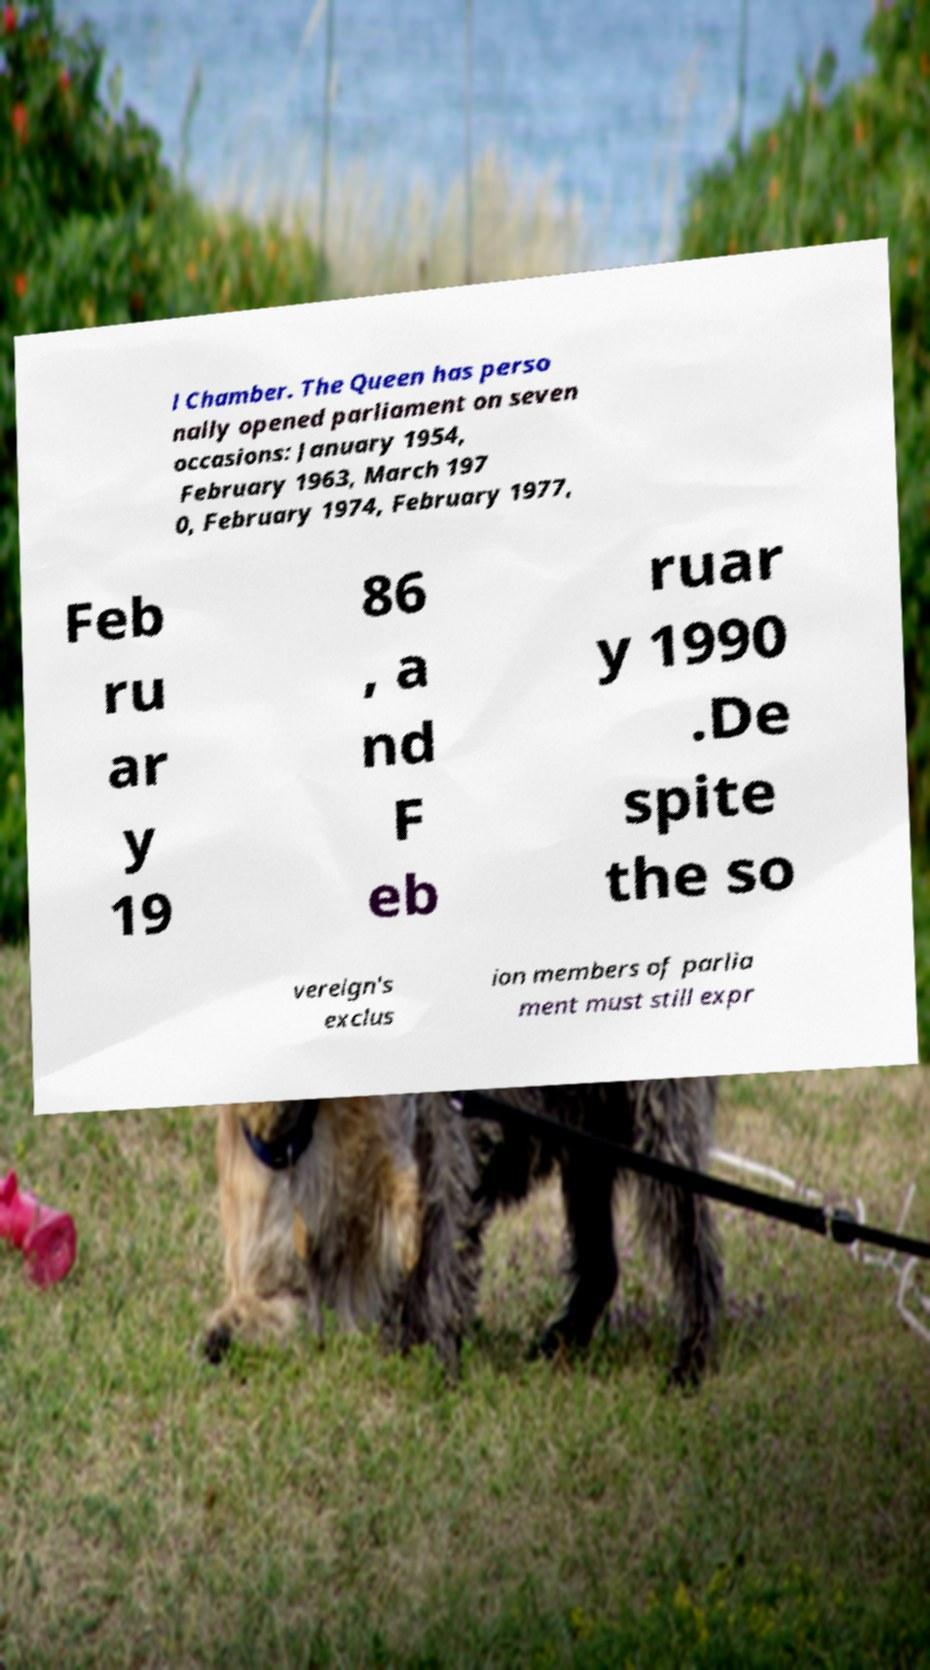For documentation purposes, I need the text within this image transcribed. Could you provide that? l Chamber. The Queen has perso nally opened parliament on seven occasions: January 1954, February 1963, March 197 0, February 1974, February 1977, Feb ru ar y 19 86 , a nd F eb ruar y 1990 .De spite the so vereign's exclus ion members of parlia ment must still expr 